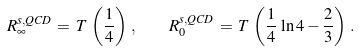Convert formula to latex. <formula><loc_0><loc_0><loc_500><loc_500>R _ { \infty } ^ { s , { Q C D } } \, = \, T \, \left ( \frac { 1 } { 4 } \right ) \, , \quad R _ { 0 } ^ { s , { Q C D } } \, = \, T \, \left ( \frac { 1 } { 4 } \, \ln 4 - \frac { 2 } { 3 } \right ) \, .</formula> 